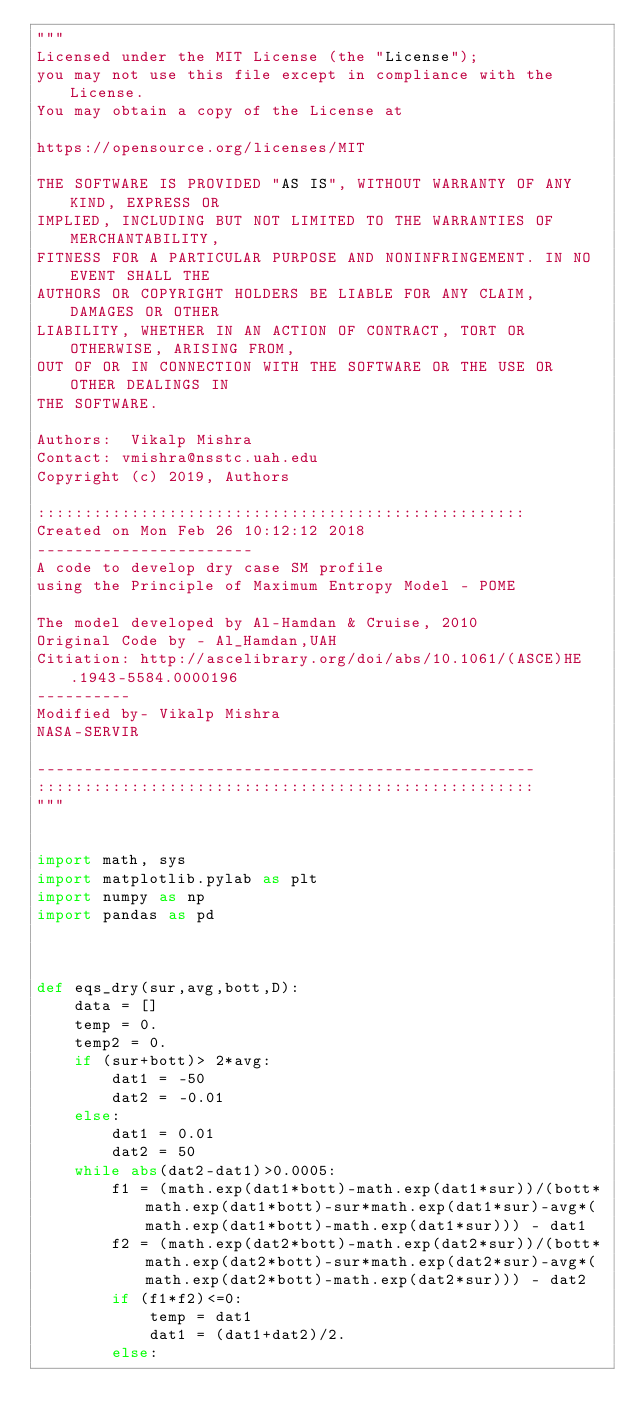Convert code to text. <code><loc_0><loc_0><loc_500><loc_500><_Python_>"""
Licensed under the MIT License (the "License");
you may not use this file except in compliance with the License.
You may obtain a copy of the License at

https://opensource.org/licenses/MIT

THE SOFTWARE IS PROVIDED "AS IS", WITHOUT WARRANTY OF ANY KIND, EXPRESS OR
IMPLIED, INCLUDING BUT NOT LIMITED TO THE WARRANTIES OF MERCHANTABILITY,
FITNESS FOR A PARTICULAR PURPOSE AND NONINFRINGEMENT. IN NO EVENT SHALL THE
AUTHORS OR COPYRIGHT HOLDERS BE LIABLE FOR ANY CLAIM, DAMAGES OR OTHER
LIABILITY, WHETHER IN AN ACTION OF CONTRACT, TORT OR OTHERWISE, ARISING FROM,
OUT OF OR IN CONNECTION WITH THE SOFTWARE OR THE USE OR OTHER DEALINGS IN
THE SOFTWARE.

Authors:  Vikalp Mishra
Contact: vmishra@nsstc.uah.edu
Copyright (c) 2019, Authors

::::::::::::::::::::::::::::::::::::::::::::::::::::
Created on Mon Feb 26 10:12:12 2018
-----------------------
A code to develop dry case SM profile
using the Principle of Maximum Entropy Model - POME

The model developed by Al-Hamdan & Cruise, 2010
Original Code by - Al_Hamdan,UAH
Citiation: http://ascelibrary.org/doi/abs/10.1061/(ASCE)HE.1943-5584.0000196
----------
Modified by- Vikalp Mishra
NASA-SERVIR

-----------------------------------------------------
:::::::::::::::::::::::::::::::::::::::::::::::::::::
"""


import math, sys
import matplotlib.pylab as plt
import numpy as np
import pandas as pd



def eqs_dry(sur,avg,bott,D):
    data = []
    temp = 0.
    temp2 = 0.    
    if (sur+bott)> 2*avg:
        dat1 = -50
        dat2 = -0.01
    else:
        dat1 = 0.01
        dat2 = 50        
    while abs(dat2-dat1)>0.0005:
        f1 = (math.exp(dat1*bott)-math.exp(dat1*sur))/(bott*math.exp(dat1*bott)-sur*math.exp(dat1*sur)-avg*(math.exp(dat1*bott)-math.exp(dat1*sur))) - dat1
        f2 = (math.exp(dat2*bott)-math.exp(dat2*sur))/(bott*math.exp(dat2*bott)-sur*math.exp(dat2*sur)-avg*(math.exp(dat2*bott)-math.exp(dat2*sur))) - dat2
        if (f1*f2)<=0:
            temp = dat1
            dat1 = (dat1+dat2)/2.
        else:</code> 